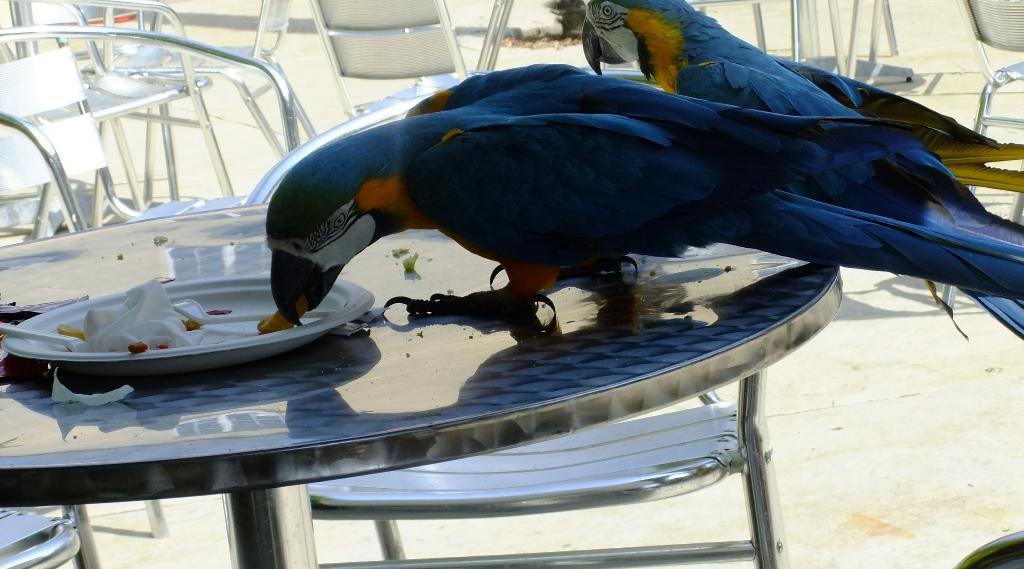Please provide a concise description of this image. This image is clicked outside. There are two birds in blue color on the table and eating food. To the left there are many chairs. At the bottom, there is ground. 